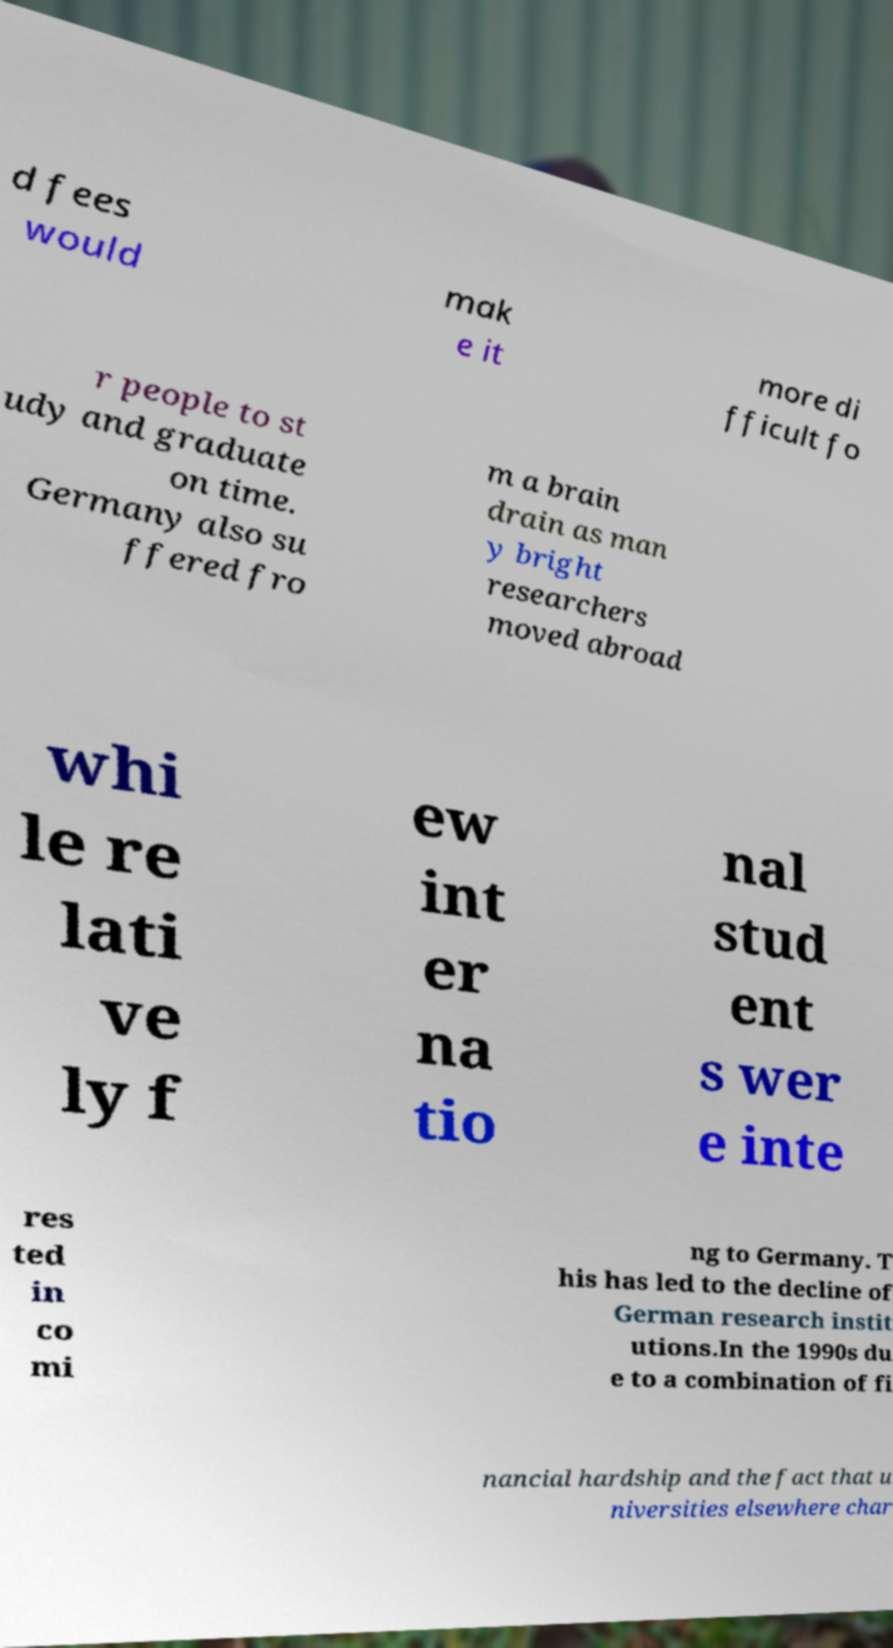Could you extract and type out the text from this image? d fees would mak e it more di fficult fo r people to st udy and graduate on time. Germany also su ffered fro m a brain drain as man y bright researchers moved abroad whi le re lati ve ly f ew int er na tio nal stud ent s wer e inte res ted in co mi ng to Germany. T his has led to the decline of German research instit utions.In the 1990s du e to a combination of fi nancial hardship and the fact that u niversities elsewhere char 